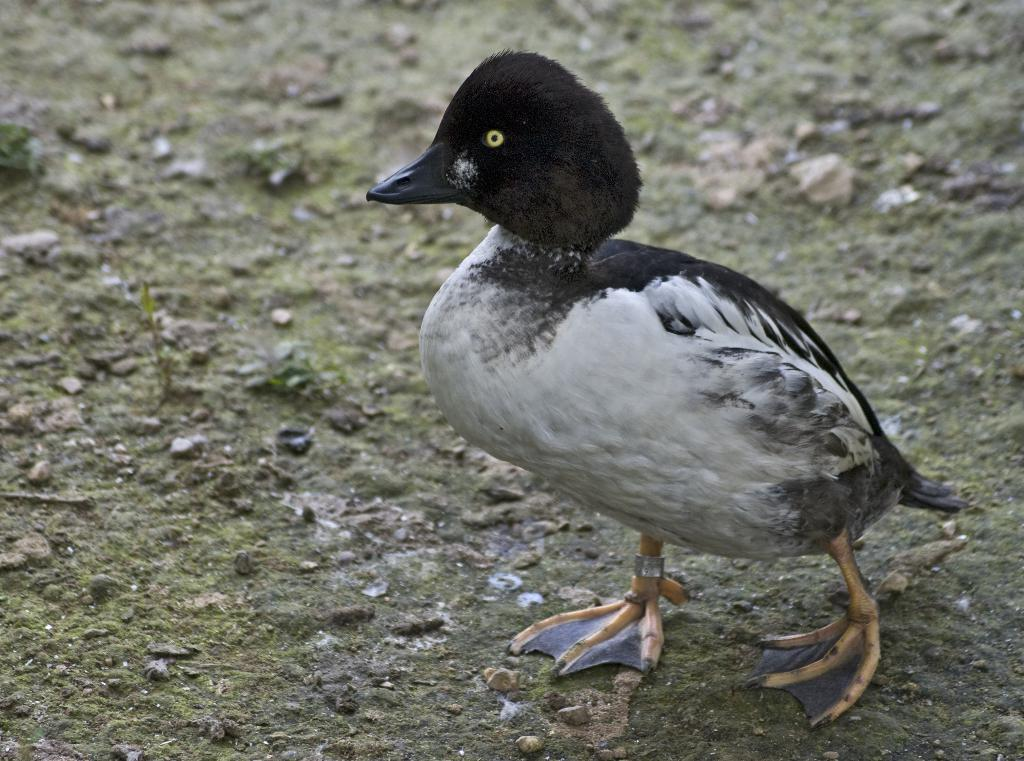What type of animal is in the image? There is a bird in the image. Where is the bird located? The bird is on the ground. What colors can be seen on the bird? The bird has white and black coloring. How many snails are crawling on the bird's beak in the image? There are no snails present in the image, and therefore no snails can be seen on the bird's beak. 